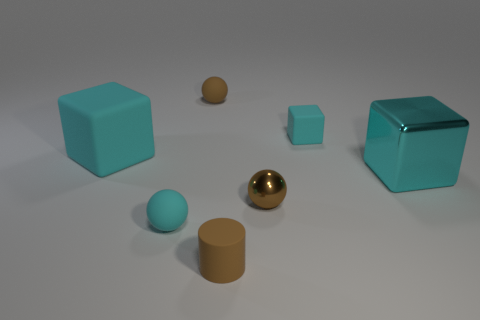Is the number of small cyan rubber blocks on the right side of the big metal object less than the number of tiny green cubes?
Your response must be concise. No. Is the number of tiny metallic objects greater than the number of purple metallic cylinders?
Give a very brief answer. Yes. Are there any big things that are in front of the cyan matte block to the left of the small matte sphere that is behind the big cyan matte object?
Your response must be concise. Yes. What number of other things are there of the same size as the cyan ball?
Your answer should be compact. 4. Are there any tiny matte cylinders left of the small brown shiny ball?
Ensure brevity in your answer.  Yes. There is a tiny cylinder; is it the same color as the shiny ball that is to the left of the cyan metal cube?
Make the answer very short. Yes. There is a tiny rubber sphere that is behind the big object that is on the right side of the cyan rubber cube that is to the left of the small metallic sphere; what is its color?
Offer a very short reply. Brown. Are there any tiny rubber things that have the same shape as the big metal object?
Keep it short and to the point. Yes. The rubber thing that is the same size as the cyan shiny cube is what color?
Provide a short and direct response. Cyan. There is a big cyan cube that is on the right side of the brown shiny object; what material is it?
Ensure brevity in your answer.  Metal. 